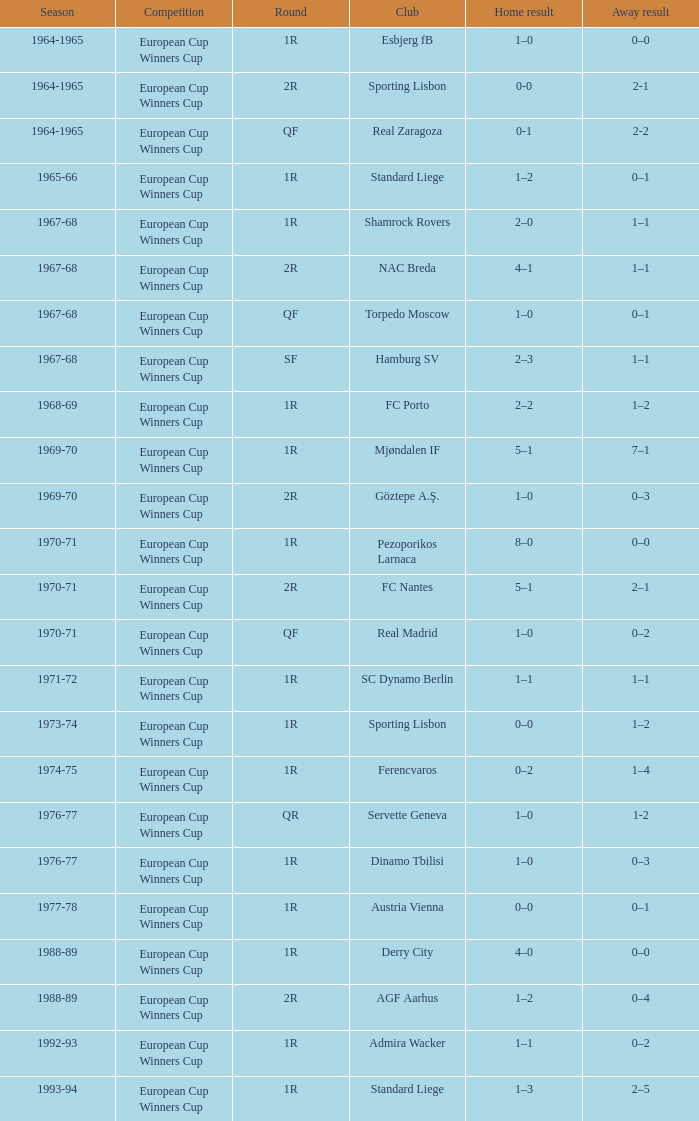Away result of 1-2 has what season? 1976-77. 